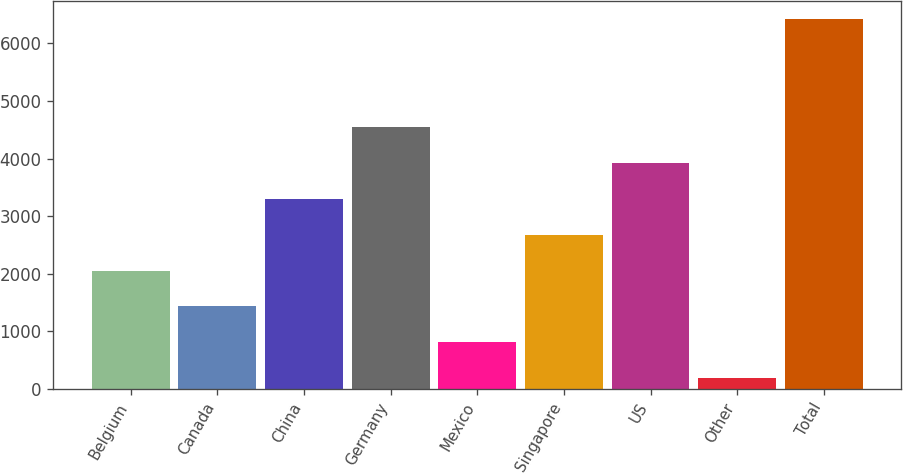Convert chart. <chart><loc_0><loc_0><loc_500><loc_500><bar_chart><fcel>Belgium<fcel>Canada<fcel>China<fcel>Germany<fcel>Mexico<fcel>Singapore<fcel>US<fcel>Other<fcel>Total<nl><fcel>2055.6<fcel>1432.4<fcel>3302<fcel>4548.4<fcel>809.2<fcel>2678.8<fcel>3925.2<fcel>186<fcel>6418<nl></chart> 